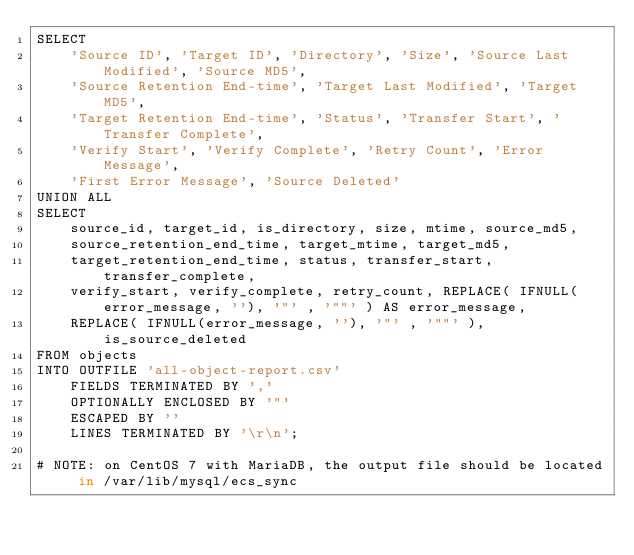<code> <loc_0><loc_0><loc_500><loc_500><_SQL_>SELECT
    'Source ID', 'Target ID', 'Directory', 'Size', 'Source Last Modified', 'Source MD5',
    'Source Retention End-time', 'Target Last Modified', 'Target MD5',
    'Target Retention End-time', 'Status', 'Transfer Start', 'Transfer Complete',
    'Verify Start', 'Verify Complete', 'Retry Count', 'Error Message',
    'First Error Message', 'Source Deleted'
UNION ALL
SELECT
    source_id, target_id, is_directory, size, mtime, source_md5,
    source_retention_end_time, target_mtime, target_md5,
    target_retention_end_time, status, transfer_start, transfer_complete,
    verify_start, verify_complete, retry_count, REPLACE( IFNULL(error_message, ''), '"' , '""' ) AS error_message,
    REPLACE( IFNULL(error_message, ''), '"' , '""' ), is_source_deleted
FROM objects
INTO OUTFILE 'all-object-report.csv'
    FIELDS TERMINATED BY ','
    OPTIONALLY ENCLOSED BY '"'
    ESCAPED BY ''
    LINES TERMINATED BY '\r\n';

# NOTE: on CentOS 7 with MariaDB, the output file should be located in /var/lib/mysql/ecs_sync</code> 